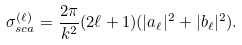Convert formula to latex. <formula><loc_0><loc_0><loc_500><loc_500>\sigma _ { s c a } ^ { ( \ell ) } = \frac { 2 \pi } { k ^ { 2 } } ( 2 \ell + 1 ) ( | a _ { \ell } | ^ { 2 } + | b _ { \ell } | ^ { 2 } ) .</formula> 